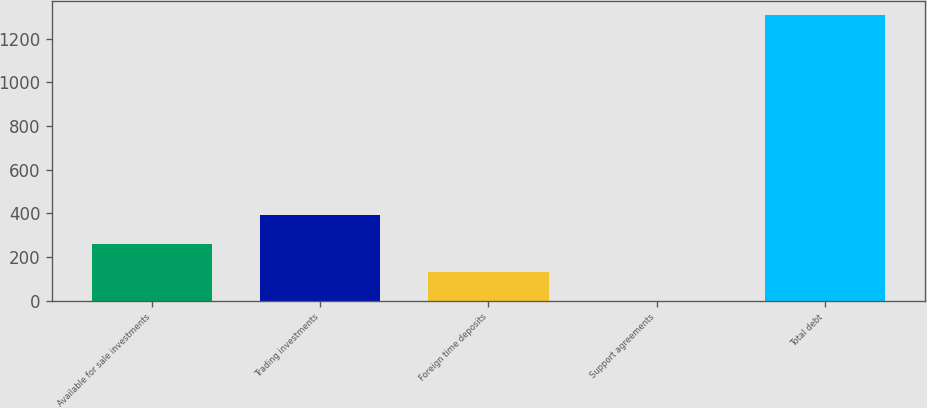<chart> <loc_0><loc_0><loc_500><loc_500><bar_chart><fcel>Available for sale investments<fcel>Trading investments<fcel>Foreign time deposits<fcel>Support agreements<fcel>Total debt<nl><fcel>262.3<fcel>392.95<fcel>131.65<fcel>1<fcel>1307.5<nl></chart> 